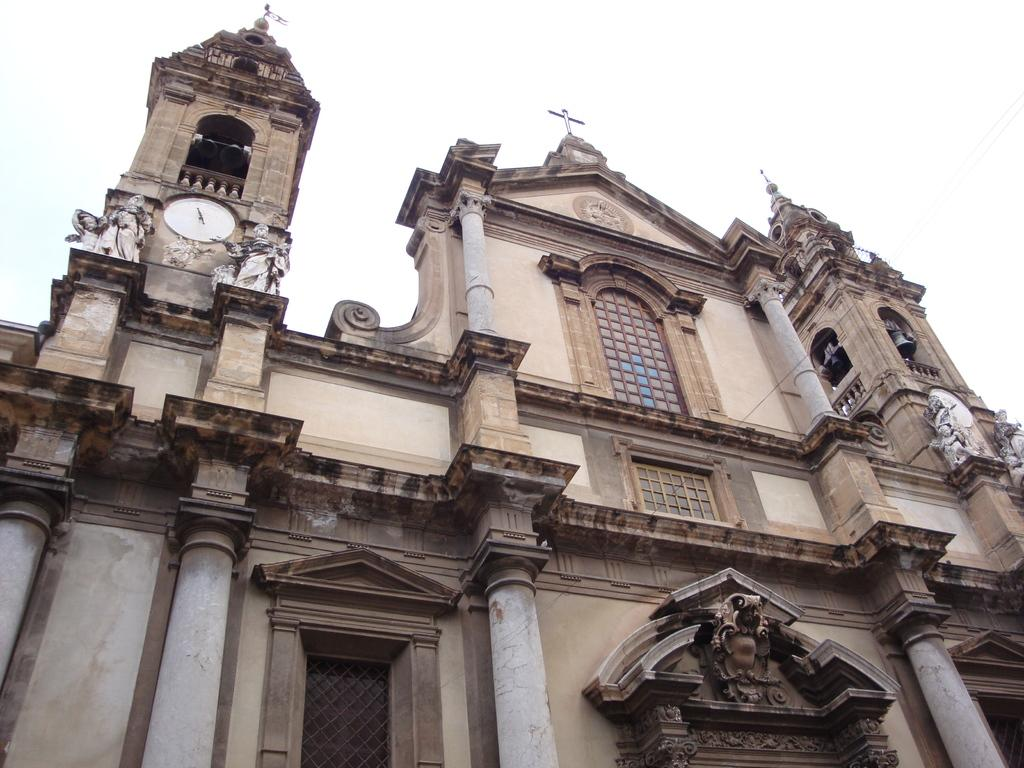What type of structure is visible in the image? There is a building in the image. Are there any additional features near the building? Yes, there are statues near the building. What can be found on the building itself? There is a clock on the building. What is the color of the sky in the background of the image? The sky is white in the background of the image. What sound can be heard coming from the statues in the image? There is no sound present in the image, as it is a still photograph. 